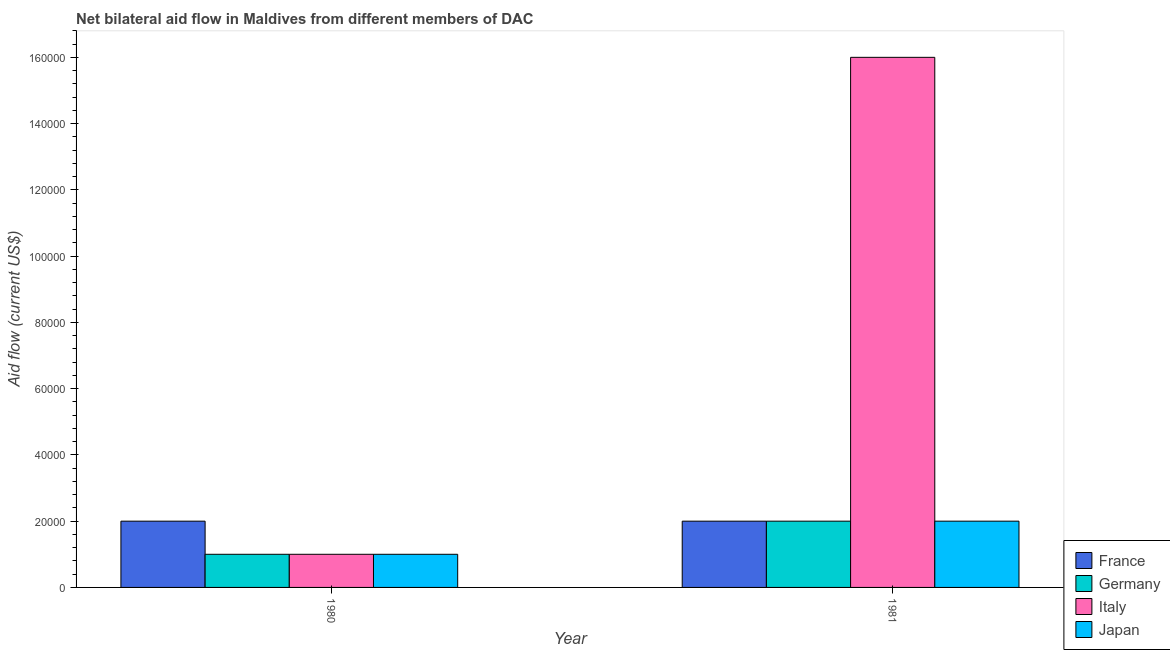Are the number of bars on each tick of the X-axis equal?
Provide a succinct answer. Yes. How many bars are there on the 1st tick from the right?
Keep it short and to the point. 4. What is the label of the 1st group of bars from the left?
Provide a short and direct response. 1980. In how many cases, is the number of bars for a given year not equal to the number of legend labels?
Give a very brief answer. 0. What is the amount of aid given by germany in 1981?
Offer a terse response. 2.00e+04. Across all years, what is the maximum amount of aid given by germany?
Keep it short and to the point. 2.00e+04. Across all years, what is the minimum amount of aid given by italy?
Provide a short and direct response. 10000. In which year was the amount of aid given by france maximum?
Offer a terse response. 1980. In which year was the amount of aid given by france minimum?
Provide a short and direct response. 1980. What is the total amount of aid given by japan in the graph?
Your answer should be very brief. 3.00e+04. What is the difference between the amount of aid given by germany in 1980 and that in 1981?
Offer a terse response. -10000. What is the average amount of aid given by japan per year?
Keep it short and to the point. 1.50e+04. In the year 1980, what is the difference between the amount of aid given by japan and amount of aid given by italy?
Provide a short and direct response. 0. In how many years, is the amount of aid given by france greater than 124000 US$?
Provide a short and direct response. 0. In how many years, is the amount of aid given by japan greater than the average amount of aid given by japan taken over all years?
Your response must be concise. 1. Is it the case that in every year, the sum of the amount of aid given by france and amount of aid given by italy is greater than the sum of amount of aid given by japan and amount of aid given by germany?
Your answer should be very brief. No. Is it the case that in every year, the sum of the amount of aid given by france and amount of aid given by germany is greater than the amount of aid given by italy?
Your answer should be very brief. No. How many bars are there?
Provide a succinct answer. 8. What is the difference between two consecutive major ticks on the Y-axis?
Provide a short and direct response. 2.00e+04. How many legend labels are there?
Make the answer very short. 4. What is the title of the graph?
Provide a succinct answer. Net bilateral aid flow in Maldives from different members of DAC. What is the label or title of the X-axis?
Provide a short and direct response. Year. What is the label or title of the Y-axis?
Offer a terse response. Aid flow (current US$). What is the Aid flow (current US$) in Japan in 1980?
Offer a terse response. 10000. What is the Aid flow (current US$) of France in 1981?
Provide a succinct answer. 2.00e+04. Across all years, what is the maximum Aid flow (current US$) of Germany?
Ensure brevity in your answer.  2.00e+04. Across all years, what is the maximum Aid flow (current US$) of Italy?
Offer a terse response. 1.60e+05. Across all years, what is the maximum Aid flow (current US$) in Japan?
Keep it short and to the point. 2.00e+04. Across all years, what is the minimum Aid flow (current US$) of France?
Provide a succinct answer. 2.00e+04. Across all years, what is the minimum Aid flow (current US$) in Germany?
Your answer should be very brief. 10000. Across all years, what is the minimum Aid flow (current US$) of Italy?
Offer a terse response. 10000. What is the total Aid flow (current US$) of Japan in the graph?
Keep it short and to the point. 3.00e+04. What is the difference between the Aid flow (current US$) in Germany in 1980 and the Aid flow (current US$) in Italy in 1981?
Provide a succinct answer. -1.50e+05. What is the difference between the Aid flow (current US$) of Germany in 1980 and the Aid flow (current US$) of Japan in 1981?
Keep it short and to the point. -10000. What is the average Aid flow (current US$) of France per year?
Ensure brevity in your answer.  2.00e+04. What is the average Aid flow (current US$) in Germany per year?
Your response must be concise. 1.50e+04. What is the average Aid flow (current US$) in Italy per year?
Give a very brief answer. 8.50e+04. What is the average Aid flow (current US$) in Japan per year?
Offer a terse response. 1.50e+04. In the year 1980, what is the difference between the Aid flow (current US$) of Germany and Aid flow (current US$) of Japan?
Provide a succinct answer. 0. In the year 1980, what is the difference between the Aid flow (current US$) of Italy and Aid flow (current US$) of Japan?
Provide a succinct answer. 0. In the year 1981, what is the difference between the Aid flow (current US$) of France and Aid flow (current US$) of Germany?
Give a very brief answer. 0. In the year 1981, what is the difference between the Aid flow (current US$) of France and Aid flow (current US$) of Japan?
Offer a very short reply. 0. In the year 1981, what is the difference between the Aid flow (current US$) in Germany and Aid flow (current US$) in Japan?
Your response must be concise. 0. What is the ratio of the Aid flow (current US$) of Italy in 1980 to that in 1981?
Your response must be concise. 0.06. What is the difference between the highest and the second highest Aid flow (current US$) in Germany?
Offer a terse response. 10000. What is the difference between the highest and the second highest Aid flow (current US$) of Italy?
Make the answer very short. 1.50e+05. What is the difference between the highest and the second highest Aid flow (current US$) of Japan?
Provide a short and direct response. 10000. What is the difference between the highest and the lowest Aid flow (current US$) of Germany?
Ensure brevity in your answer.  10000. What is the difference between the highest and the lowest Aid flow (current US$) of Japan?
Give a very brief answer. 10000. 